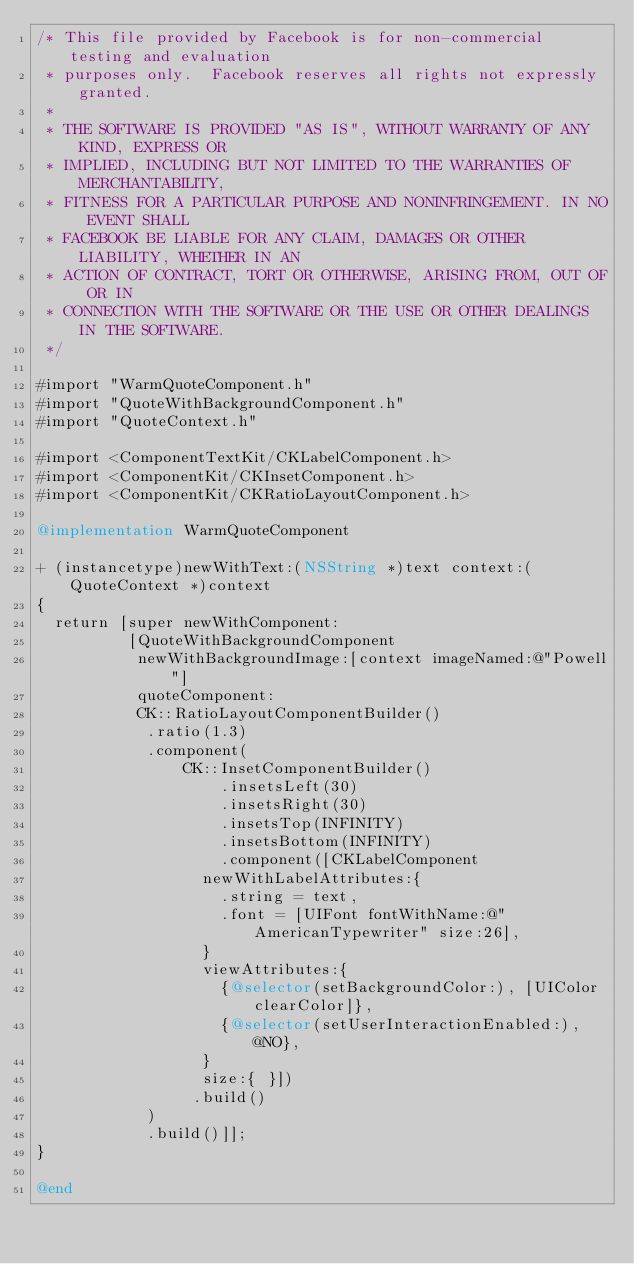<code> <loc_0><loc_0><loc_500><loc_500><_ObjectiveC_>/* This file provided by Facebook is for non-commercial testing and evaluation
 * purposes only.  Facebook reserves all rights not expressly granted.
 *
 * THE SOFTWARE IS PROVIDED "AS IS", WITHOUT WARRANTY OF ANY KIND, EXPRESS OR
 * IMPLIED, INCLUDING BUT NOT LIMITED TO THE WARRANTIES OF MERCHANTABILITY,
 * FITNESS FOR A PARTICULAR PURPOSE AND NONINFRINGEMENT. IN NO EVENT SHALL
 * FACEBOOK BE LIABLE FOR ANY CLAIM, DAMAGES OR OTHER LIABILITY, WHETHER IN AN
 * ACTION OF CONTRACT, TORT OR OTHERWISE, ARISING FROM, OUT OF OR IN
 * CONNECTION WITH THE SOFTWARE OR THE USE OR OTHER DEALINGS IN THE SOFTWARE.
 */

#import "WarmQuoteComponent.h"
#import "QuoteWithBackgroundComponent.h"
#import "QuoteContext.h"

#import <ComponentTextKit/CKLabelComponent.h>
#import <ComponentKit/CKInsetComponent.h>
#import <ComponentKit/CKRatioLayoutComponent.h>

@implementation WarmQuoteComponent

+ (instancetype)newWithText:(NSString *)text context:(QuoteContext *)context
{
  return [super newWithComponent:
          [QuoteWithBackgroundComponent
           newWithBackgroundImage:[context imageNamed:@"Powell"]
           quoteComponent:
           CK::RatioLayoutComponentBuilder()
            .ratio(1.3)
            .component(
                CK::InsetComponentBuilder()
                    .insetsLeft(30)
                    .insetsRight(30)
                    .insetsTop(INFINITY)
                    .insetsBottom(INFINITY)
                    .component([CKLabelComponent
                  newWithLabelAttributes:{
                    .string = text,
                    .font = [UIFont fontWithName:@"AmericanTypewriter" size:26],
                  }
                  viewAttributes:{
                    {@selector(setBackgroundColor:), [UIColor clearColor]},
                    {@selector(setUserInteractionEnabled:), @NO},
                  }
                  size:{ }])
                 .build()
            )
            .build()]];
}

@end
</code> 